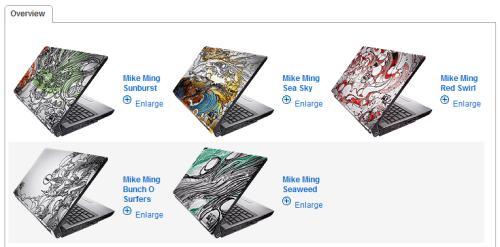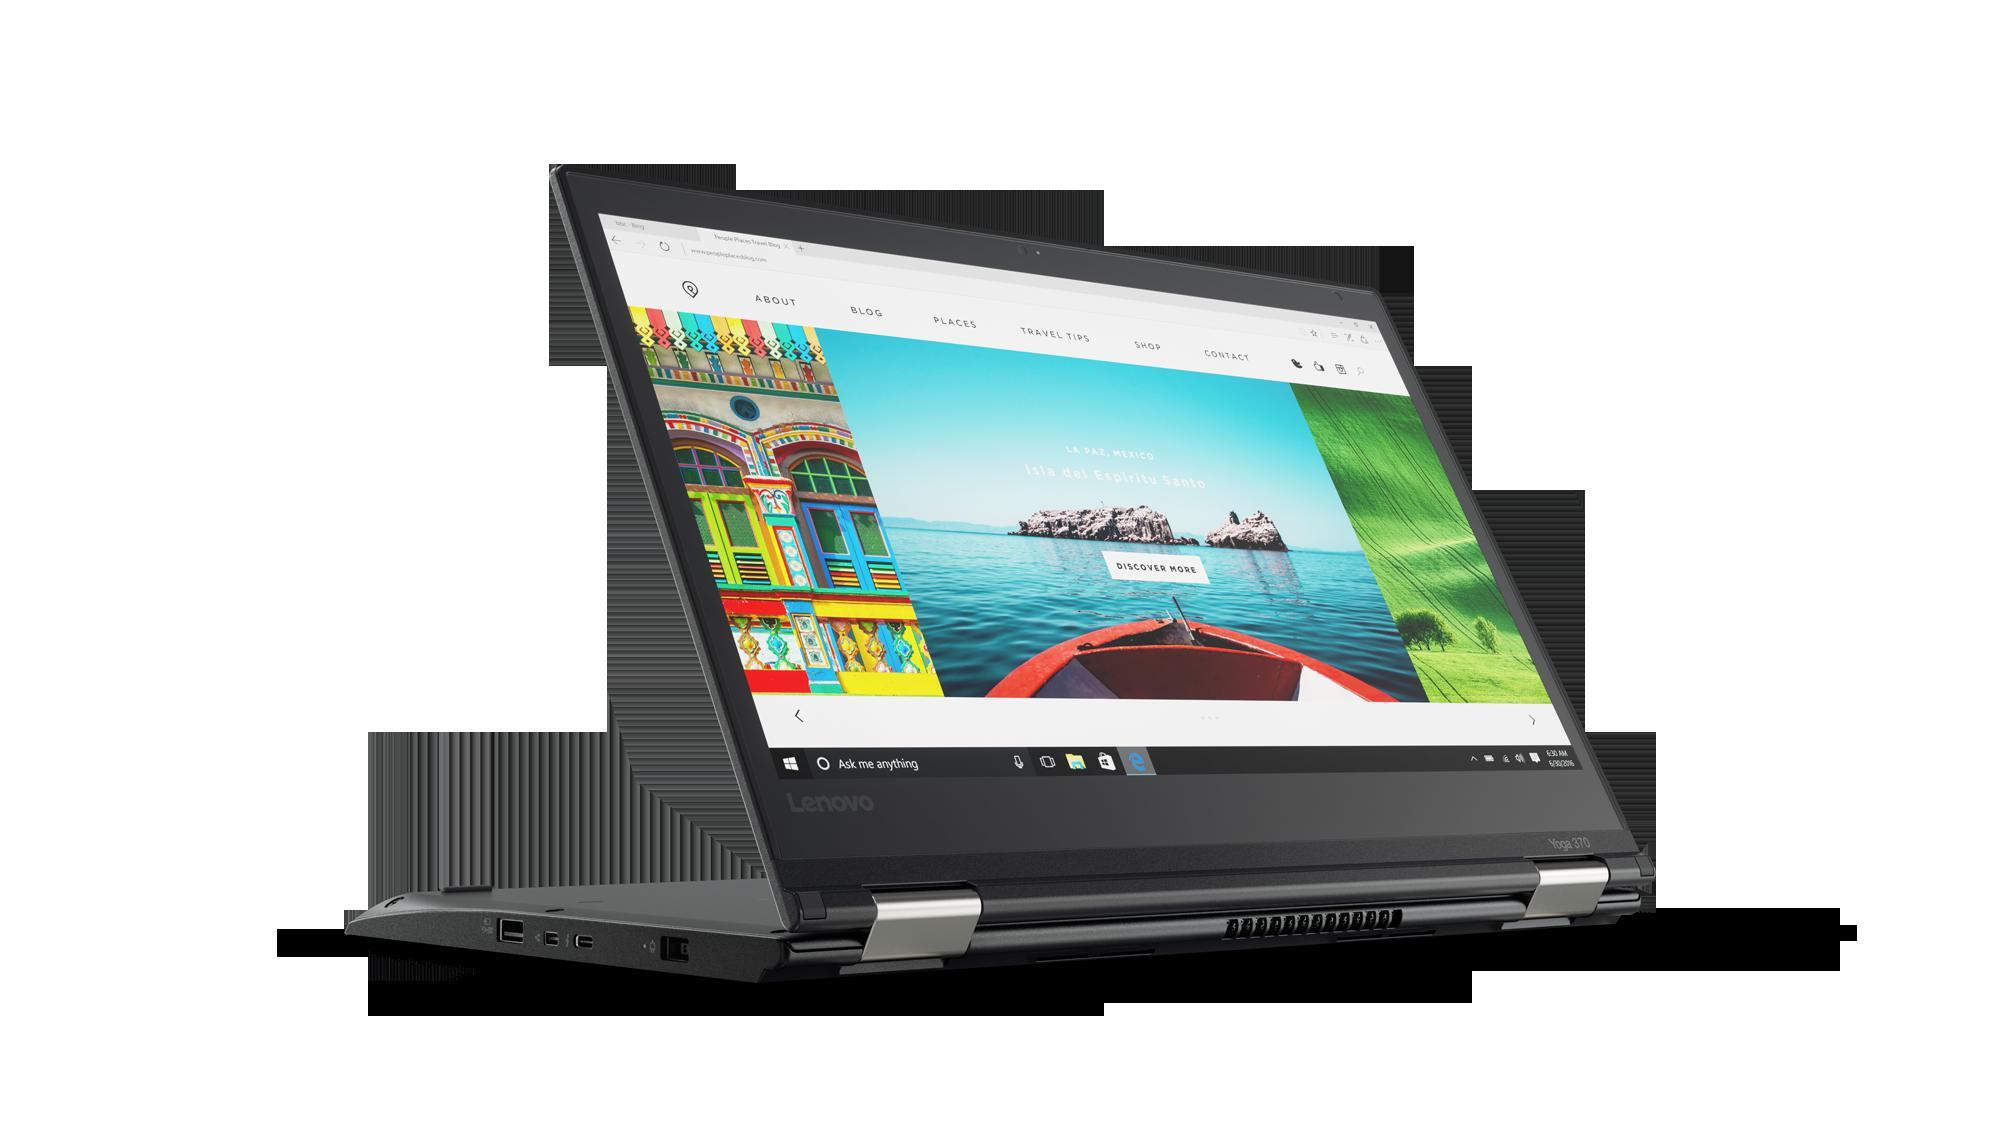The first image is the image on the left, the second image is the image on the right. Given the left and right images, does the statement "The right image shows exactly one laptop with a picture on the back facing outward, and the left image includes at least two laptops that are at least partly open." hold true? Answer yes or no. Yes. 